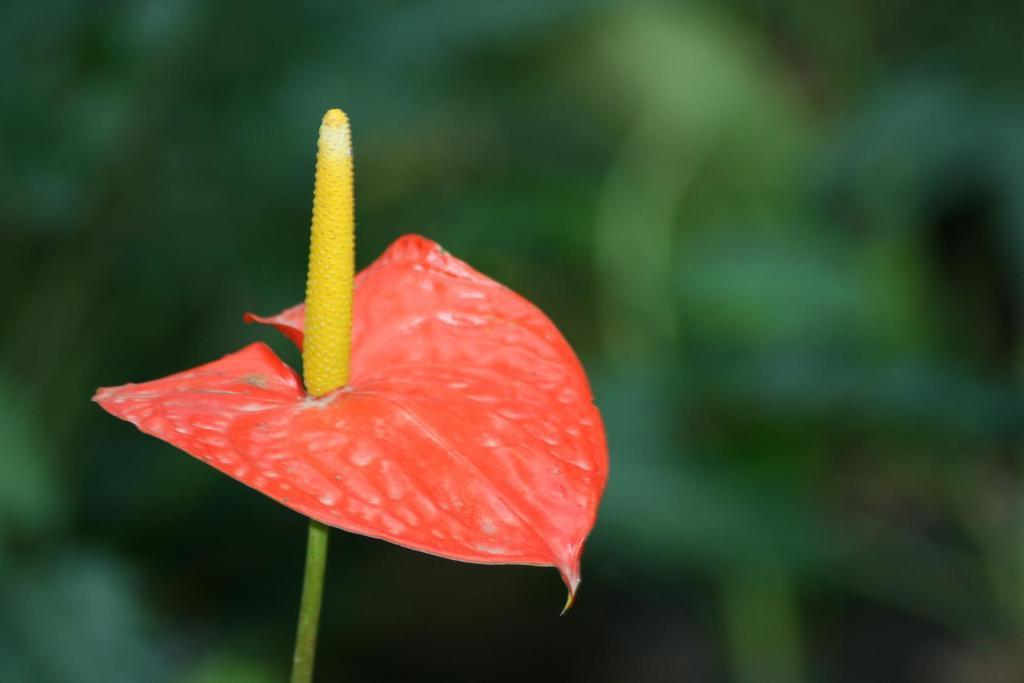What is present in the image? There is a plant in the image. What color is the leaf of the plant? The leaf of the plant is red. Can you describe the background of the image? The background of the image is blurred. How many planes can be seen flying over the plantation in the image? There are no planes or plantations present in the image; it features a plant with a red leaf and a blurred background. 